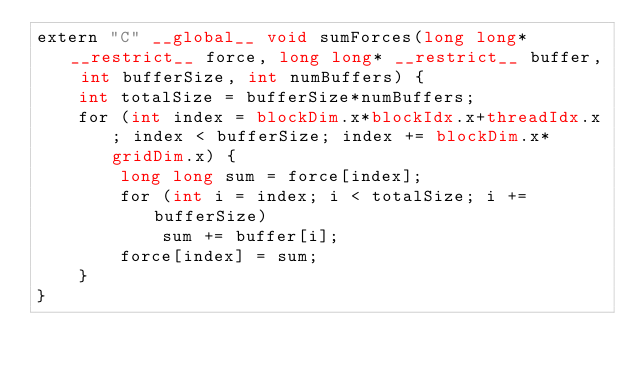<code> <loc_0><loc_0><loc_500><loc_500><_Cuda_>extern "C" __global__ void sumForces(long long* __restrict__ force, long long* __restrict__ buffer, int bufferSize, int numBuffers) {
    int totalSize = bufferSize*numBuffers;
    for (int index = blockDim.x*blockIdx.x+threadIdx.x; index < bufferSize; index += blockDim.x*gridDim.x) {
        long long sum = force[index];
        for (int i = index; i < totalSize; i += bufferSize)
            sum += buffer[i];
        force[index] = sum;
    }
}
</code> 